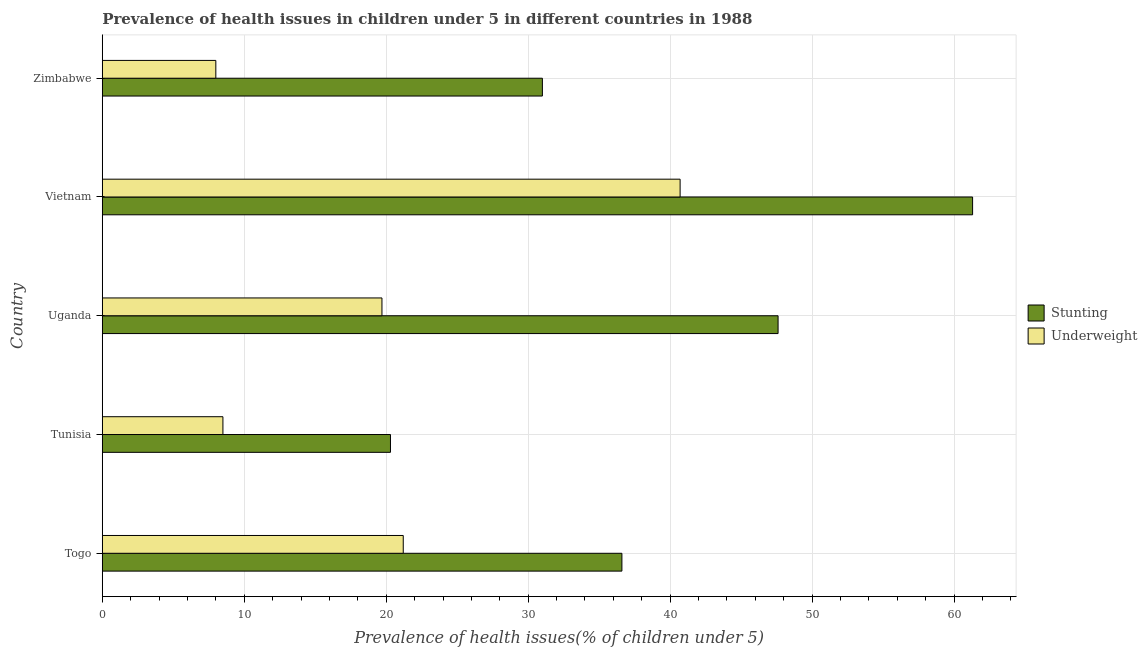How many different coloured bars are there?
Ensure brevity in your answer.  2. How many groups of bars are there?
Provide a succinct answer. 5. Are the number of bars per tick equal to the number of legend labels?
Make the answer very short. Yes. How many bars are there on the 5th tick from the top?
Give a very brief answer. 2. What is the label of the 2nd group of bars from the top?
Provide a succinct answer. Vietnam. What is the percentage of stunted children in Zimbabwe?
Offer a terse response. 31. Across all countries, what is the maximum percentage of underweight children?
Make the answer very short. 40.7. In which country was the percentage of underweight children maximum?
Make the answer very short. Vietnam. In which country was the percentage of stunted children minimum?
Offer a very short reply. Tunisia. What is the total percentage of stunted children in the graph?
Offer a terse response. 196.8. What is the difference between the percentage of stunted children in Uganda and that in Vietnam?
Give a very brief answer. -13.7. What is the difference between the percentage of underweight children in Zimbabwe and the percentage of stunted children in Tunisia?
Offer a very short reply. -12.3. What is the average percentage of stunted children per country?
Give a very brief answer. 39.36. What is the difference between the percentage of stunted children and percentage of underweight children in Vietnam?
Keep it short and to the point. 20.6. What is the ratio of the percentage of underweight children in Togo to that in Vietnam?
Provide a short and direct response. 0.52. Is the difference between the percentage of stunted children in Tunisia and Vietnam greater than the difference between the percentage of underweight children in Tunisia and Vietnam?
Offer a very short reply. No. What is the difference between the highest and the lowest percentage of underweight children?
Keep it short and to the point. 32.7. In how many countries, is the percentage of underweight children greater than the average percentage of underweight children taken over all countries?
Offer a very short reply. 3. Is the sum of the percentage of underweight children in Tunisia and Zimbabwe greater than the maximum percentage of stunted children across all countries?
Make the answer very short. No. What does the 2nd bar from the top in Vietnam represents?
Offer a very short reply. Stunting. What does the 1st bar from the bottom in Uganda represents?
Your response must be concise. Stunting. How many countries are there in the graph?
Offer a terse response. 5. Are the values on the major ticks of X-axis written in scientific E-notation?
Give a very brief answer. No. Does the graph contain grids?
Provide a short and direct response. Yes. Where does the legend appear in the graph?
Ensure brevity in your answer.  Center right. How are the legend labels stacked?
Give a very brief answer. Vertical. What is the title of the graph?
Keep it short and to the point. Prevalence of health issues in children under 5 in different countries in 1988. Does "Official aid received" appear as one of the legend labels in the graph?
Provide a short and direct response. No. What is the label or title of the X-axis?
Make the answer very short. Prevalence of health issues(% of children under 5). What is the Prevalence of health issues(% of children under 5) in Stunting in Togo?
Keep it short and to the point. 36.6. What is the Prevalence of health issues(% of children under 5) in Underweight in Togo?
Ensure brevity in your answer.  21.2. What is the Prevalence of health issues(% of children under 5) in Stunting in Tunisia?
Offer a very short reply. 20.3. What is the Prevalence of health issues(% of children under 5) of Stunting in Uganda?
Provide a short and direct response. 47.6. What is the Prevalence of health issues(% of children under 5) in Underweight in Uganda?
Give a very brief answer. 19.7. What is the Prevalence of health issues(% of children under 5) in Stunting in Vietnam?
Provide a succinct answer. 61.3. What is the Prevalence of health issues(% of children under 5) of Underweight in Vietnam?
Make the answer very short. 40.7. What is the Prevalence of health issues(% of children under 5) in Stunting in Zimbabwe?
Provide a succinct answer. 31. What is the Prevalence of health issues(% of children under 5) of Underweight in Zimbabwe?
Give a very brief answer. 8. Across all countries, what is the maximum Prevalence of health issues(% of children under 5) in Stunting?
Provide a short and direct response. 61.3. Across all countries, what is the maximum Prevalence of health issues(% of children under 5) of Underweight?
Your answer should be compact. 40.7. Across all countries, what is the minimum Prevalence of health issues(% of children under 5) in Stunting?
Your answer should be compact. 20.3. What is the total Prevalence of health issues(% of children under 5) of Stunting in the graph?
Your answer should be compact. 196.8. What is the total Prevalence of health issues(% of children under 5) of Underweight in the graph?
Provide a succinct answer. 98.1. What is the difference between the Prevalence of health issues(% of children under 5) of Stunting in Togo and that in Tunisia?
Your response must be concise. 16.3. What is the difference between the Prevalence of health issues(% of children under 5) of Underweight in Togo and that in Tunisia?
Provide a short and direct response. 12.7. What is the difference between the Prevalence of health issues(% of children under 5) of Stunting in Togo and that in Uganda?
Offer a very short reply. -11. What is the difference between the Prevalence of health issues(% of children under 5) of Stunting in Togo and that in Vietnam?
Make the answer very short. -24.7. What is the difference between the Prevalence of health issues(% of children under 5) in Underweight in Togo and that in Vietnam?
Give a very brief answer. -19.5. What is the difference between the Prevalence of health issues(% of children under 5) of Stunting in Tunisia and that in Uganda?
Your response must be concise. -27.3. What is the difference between the Prevalence of health issues(% of children under 5) in Underweight in Tunisia and that in Uganda?
Make the answer very short. -11.2. What is the difference between the Prevalence of health issues(% of children under 5) in Stunting in Tunisia and that in Vietnam?
Ensure brevity in your answer.  -41. What is the difference between the Prevalence of health issues(% of children under 5) of Underweight in Tunisia and that in Vietnam?
Your answer should be compact. -32.2. What is the difference between the Prevalence of health issues(% of children under 5) of Stunting in Tunisia and that in Zimbabwe?
Provide a short and direct response. -10.7. What is the difference between the Prevalence of health issues(% of children under 5) in Underweight in Tunisia and that in Zimbabwe?
Ensure brevity in your answer.  0.5. What is the difference between the Prevalence of health issues(% of children under 5) of Stunting in Uganda and that in Vietnam?
Ensure brevity in your answer.  -13.7. What is the difference between the Prevalence of health issues(% of children under 5) in Underweight in Uganda and that in Vietnam?
Keep it short and to the point. -21. What is the difference between the Prevalence of health issues(% of children under 5) in Stunting in Uganda and that in Zimbabwe?
Ensure brevity in your answer.  16.6. What is the difference between the Prevalence of health issues(% of children under 5) in Underweight in Uganda and that in Zimbabwe?
Offer a very short reply. 11.7. What is the difference between the Prevalence of health issues(% of children under 5) in Stunting in Vietnam and that in Zimbabwe?
Give a very brief answer. 30.3. What is the difference between the Prevalence of health issues(% of children under 5) of Underweight in Vietnam and that in Zimbabwe?
Make the answer very short. 32.7. What is the difference between the Prevalence of health issues(% of children under 5) in Stunting in Togo and the Prevalence of health issues(% of children under 5) in Underweight in Tunisia?
Offer a terse response. 28.1. What is the difference between the Prevalence of health issues(% of children under 5) in Stunting in Togo and the Prevalence of health issues(% of children under 5) in Underweight in Uganda?
Give a very brief answer. 16.9. What is the difference between the Prevalence of health issues(% of children under 5) of Stunting in Togo and the Prevalence of health issues(% of children under 5) of Underweight in Zimbabwe?
Keep it short and to the point. 28.6. What is the difference between the Prevalence of health issues(% of children under 5) in Stunting in Tunisia and the Prevalence of health issues(% of children under 5) in Underweight in Uganda?
Provide a succinct answer. 0.6. What is the difference between the Prevalence of health issues(% of children under 5) of Stunting in Tunisia and the Prevalence of health issues(% of children under 5) of Underweight in Vietnam?
Offer a terse response. -20.4. What is the difference between the Prevalence of health issues(% of children under 5) in Stunting in Uganda and the Prevalence of health issues(% of children under 5) in Underweight in Vietnam?
Provide a succinct answer. 6.9. What is the difference between the Prevalence of health issues(% of children under 5) of Stunting in Uganda and the Prevalence of health issues(% of children under 5) of Underweight in Zimbabwe?
Provide a succinct answer. 39.6. What is the difference between the Prevalence of health issues(% of children under 5) in Stunting in Vietnam and the Prevalence of health issues(% of children under 5) in Underweight in Zimbabwe?
Make the answer very short. 53.3. What is the average Prevalence of health issues(% of children under 5) in Stunting per country?
Your answer should be very brief. 39.36. What is the average Prevalence of health issues(% of children under 5) in Underweight per country?
Ensure brevity in your answer.  19.62. What is the difference between the Prevalence of health issues(% of children under 5) in Stunting and Prevalence of health issues(% of children under 5) in Underweight in Uganda?
Keep it short and to the point. 27.9. What is the difference between the Prevalence of health issues(% of children under 5) of Stunting and Prevalence of health issues(% of children under 5) of Underweight in Vietnam?
Provide a short and direct response. 20.6. What is the difference between the Prevalence of health issues(% of children under 5) of Stunting and Prevalence of health issues(% of children under 5) of Underweight in Zimbabwe?
Your answer should be very brief. 23. What is the ratio of the Prevalence of health issues(% of children under 5) in Stunting in Togo to that in Tunisia?
Provide a short and direct response. 1.8. What is the ratio of the Prevalence of health issues(% of children under 5) of Underweight in Togo to that in Tunisia?
Your answer should be compact. 2.49. What is the ratio of the Prevalence of health issues(% of children under 5) of Stunting in Togo to that in Uganda?
Your answer should be very brief. 0.77. What is the ratio of the Prevalence of health issues(% of children under 5) in Underweight in Togo to that in Uganda?
Make the answer very short. 1.08. What is the ratio of the Prevalence of health issues(% of children under 5) of Stunting in Togo to that in Vietnam?
Keep it short and to the point. 0.6. What is the ratio of the Prevalence of health issues(% of children under 5) in Underweight in Togo to that in Vietnam?
Offer a terse response. 0.52. What is the ratio of the Prevalence of health issues(% of children under 5) of Stunting in Togo to that in Zimbabwe?
Your answer should be very brief. 1.18. What is the ratio of the Prevalence of health issues(% of children under 5) in Underweight in Togo to that in Zimbabwe?
Give a very brief answer. 2.65. What is the ratio of the Prevalence of health issues(% of children under 5) of Stunting in Tunisia to that in Uganda?
Your answer should be very brief. 0.43. What is the ratio of the Prevalence of health issues(% of children under 5) of Underweight in Tunisia to that in Uganda?
Ensure brevity in your answer.  0.43. What is the ratio of the Prevalence of health issues(% of children under 5) of Stunting in Tunisia to that in Vietnam?
Your answer should be compact. 0.33. What is the ratio of the Prevalence of health issues(% of children under 5) in Underweight in Tunisia to that in Vietnam?
Keep it short and to the point. 0.21. What is the ratio of the Prevalence of health issues(% of children under 5) in Stunting in Tunisia to that in Zimbabwe?
Your answer should be compact. 0.65. What is the ratio of the Prevalence of health issues(% of children under 5) in Stunting in Uganda to that in Vietnam?
Keep it short and to the point. 0.78. What is the ratio of the Prevalence of health issues(% of children under 5) of Underweight in Uganda to that in Vietnam?
Keep it short and to the point. 0.48. What is the ratio of the Prevalence of health issues(% of children under 5) of Stunting in Uganda to that in Zimbabwe?
Provide a succinct answer. 1.54. What is the ratio of the Prevalence of health issues(% of children under 5) in Underweight in Uganda to that in Zimbabwe?
Your response must be concise. 2.46. What is the ratio of the Prevalence of health issues(% of children under 5) in Stunting in Vietnam to that in Zimbabwe?
Offer a very short reply. 1.98. What is the ratio of the Prevalence of health issues(% of children under 5) of Underweight in Vietnam to that in Zimbabwe?
Your answer should be very brief. 5.09. What is the difference between the highest and the second highest Prevalence of health issues(% of children under 5) of Stunting?
Keep it short and to the point. 13.7. What is the difference between the highest and the second highest Prevalence of health issues(% of children under 5) in Underweight?
Your response must be concise. 19.5. What is the difference between the highest and the lowest Prevalence of health issues(% of children under 5) in Stunting?
Your answer should be very brief. 41. What is the difference between the highest and the lowest Prevalence of health issues(% of children under 5) of Underweight?
Give a very brief answer. 32.7. 